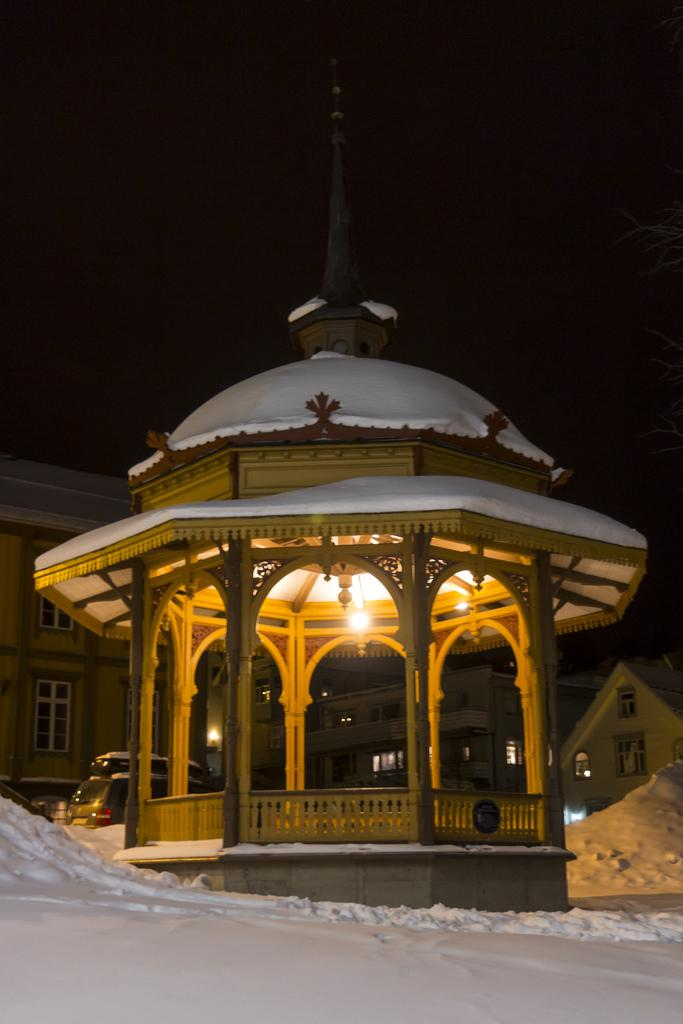What structure is located in the center of the image? There is a gazebo in the center of the image. What can be seen in the background of the image? There are buildings and sheds in the background of the image. What is the ground covered with in the image? There is snow at the bottom of the image. What is visible in the sky in the image? The sky is visible in the background of the image. Where is the crown placed in the image? There is no crown present in the image. What type of canvas is used to create the image? The image is not a painting or drawing, so there is no canvas used to create it. 